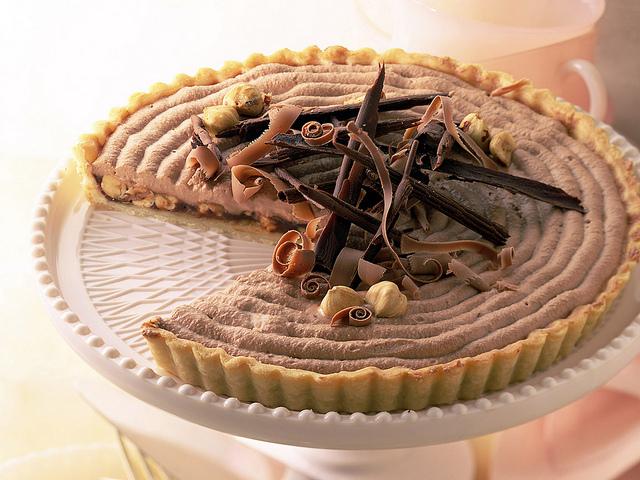What flavor is this dessert?
Write a very short answer. Chocolate. What is on top of the pastry?
Quick response, please. Chocolate. Is there any pieces missing?
Be succinct. Yes. 